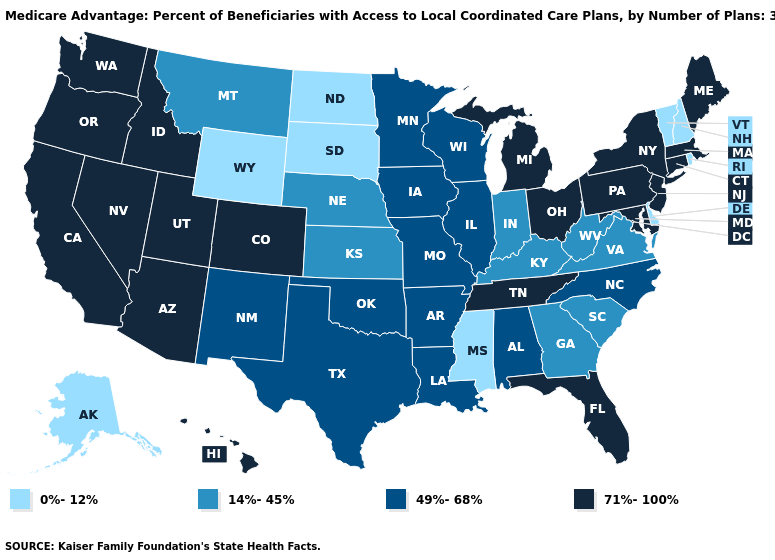Does Kentucky have the same value as Pennsylvania?
Quick response, please. No. Does Pennsylvania have the highest value in the USA?
Write a very short answer. Yes. Does the map have missing data?
Be succinct. No. Among the states that border New Mexico , which have the lowest value?
Give a very brief answer. Oklahoma, Texas. What is the value of Pennsylvania?
Give a very brief answer. 71%-100%. Name the states that have a value in the range 49%-68%?
Concise answer only. Alabama, Arkansas, Iowa, Illinois, Louisiana, Minnesota, Missouri, North Carolina, New Mexico, Oklahoma, Texas, Wisconsin. What is the value of Rhode Island?
Be succinct. 0%-12%. Among the states that border South Dakota , which have the lowest value?
Concise answer only. North Dakota, Wyoming. How many symbols are there in the legend?
Quick response, please. 4. Which states have the lowest value in the USA?
Give a very brief answer. Alaska, Delaware, Mississippi, North Dakota, New Hampshire, Rhode Island, South Dakota, Vermont, Wyoming. Does Missouri have the lowest value in the USA?
Short answer required. No. What is the lowest value in the USA?
Quick response, please. 0%-12%. Which states have the lowest value in the West?
Concise answer only. Alaska, Wyoming. Does Ohio have the lowest value in the USA?
Keep it brief. No. 